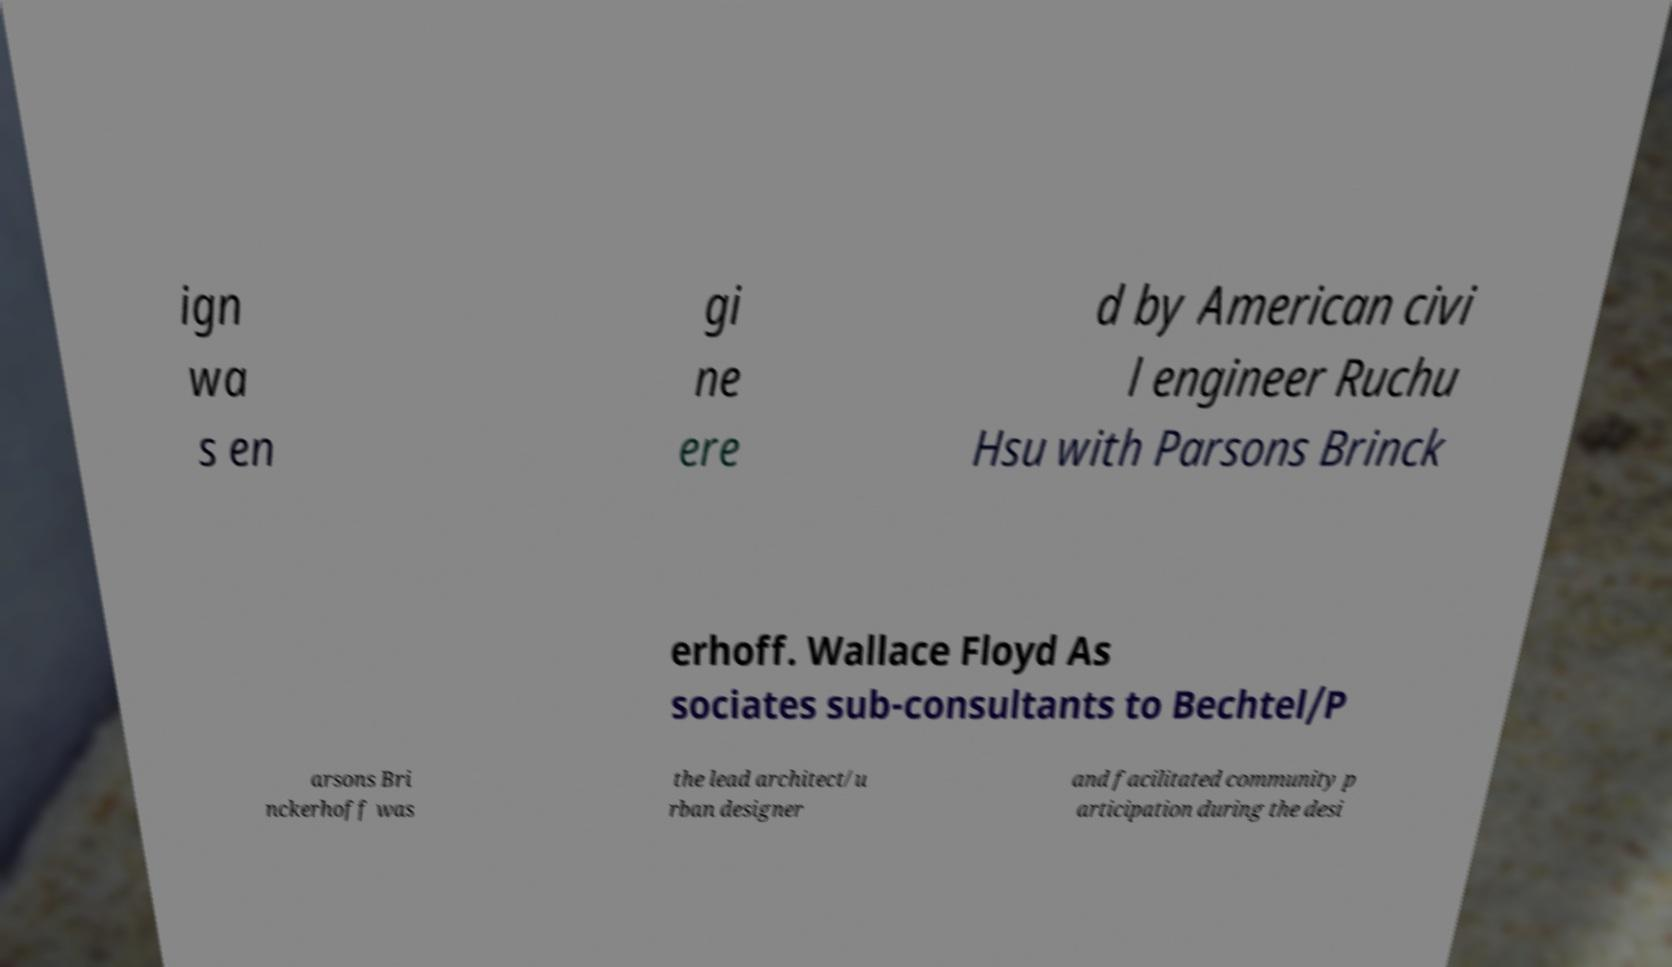Could you assist in decoding the text presented in this image and type it out clearly? ign wa s en gi ne ere d by American civi l engineer Ruchu Hsu with Parsons Brinck erhoff. Wallace Floyd As sociates sub-consultants to Bechtel/P arsons Bri nckerhoff was the lead architect/u rban designer and facilitated community p articipation during the desi 